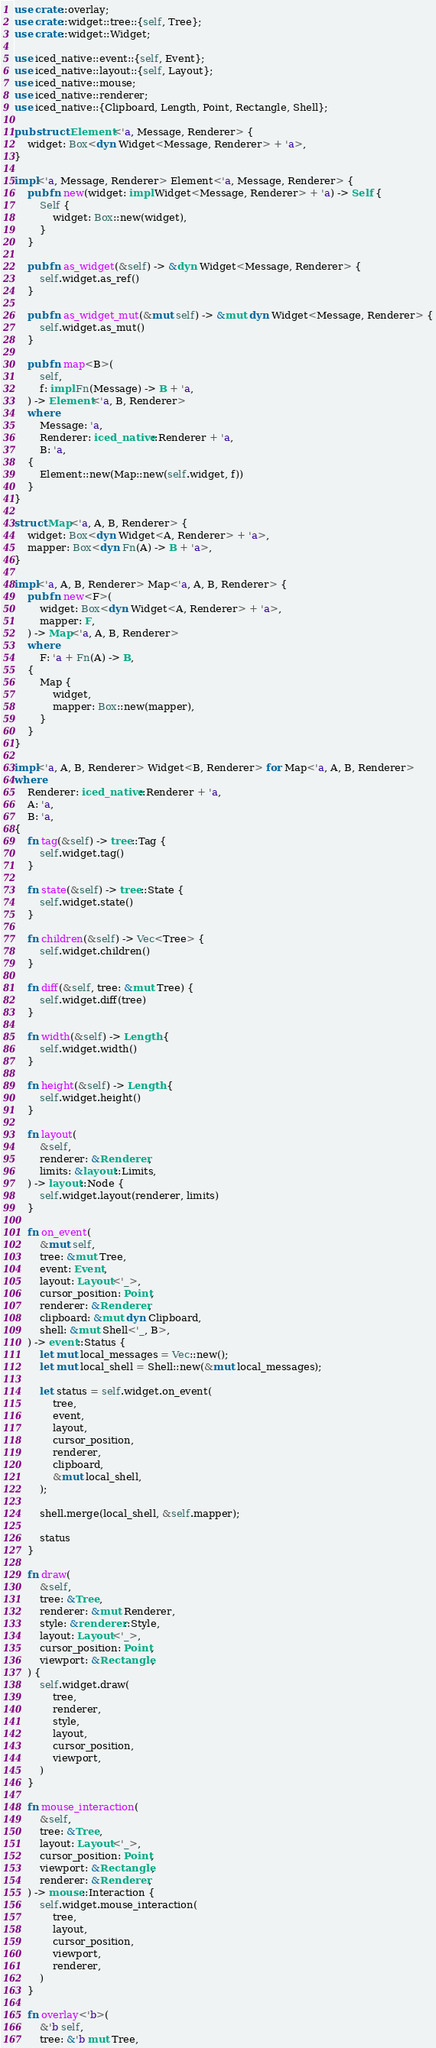Convert code to text. <code><loc_0><loc_0><loc_500><loc_500><_Rust_>use crate::overlay;
use crate::widget::tree::{self, Tree};
use crate::widget::Widget;

use iced_native::event::{self, Event};
use iced_native::layout::{self, Layout};
use iced_native::mouse;
use iced_native::renderer;
use iced_native::{Clipboard, Length, Point, Rectangle, Shell};

pub struct Element<'a, Message, Renderer> {
    widget: Box<dyn Widget<Message, Renderer> + 'a>,
}

impl<'a, Message, Renderer> Element<'a, Message, Renderer> {
    pub fn new(widget: impl Widget<Message, Renderer> + 'a) -> Self {
        Self {
            widget: Box::new(widget),
        }
    }

    pub fn as_widget(&self) -> &dyn Widget<Message, Renderer> {
        self.widget.as_ref()
    }

    pub fn as_widget_mut(&mut self) -> &mut dyn Widget<Message, Renderer> {
        self.widget.as_mut()
    }

    pub fn map<B>(
        self,
        f: impl Fn(Message) -> B + 'a,
    ) -> Element<'a, B, Renderer>
    where
        Message: 'a,
        Renderer: iced_native::Renderer + 'a,
        B: 'a,
    {
        Element::new(Map::new(self.widget, f))
    }
}

struct Map<'a, A, B, Renderer> {
    widget: Box<dyn Widget<A, Renderer> + 'a>,
    mapper: Box<dyn Fn(A) -> B + 'a>,
}

impl<'a, A, B, Renderer> Map<'a, A, B, Renderer> {
    pub fn new<F>(
        widget: Box<dyn Widget<A, Renderer> + 'a>,
        mapper: F,
    ) -> Map<'a, A, B, Renderer>
    where
        F: 'a + Fn(A) -> B,
    {
        Map {
            widget,
            mapper: Box::new(mapper),
        }
    }
}

impl<'a, A, B, Renderer> Widget<B, Renderer> for Map<'a, A, B, Renderer>
where
    Renderer: iced_native::Renderer + 'a,
    A: 'a,
    B: 'a,
{
    fn tag(&self) -> tree::Tag {
        self.widget.tag()
    }

    fn state(&self) -> tree::State {
        self.widget.state()
    }

    fn children(&self) -> Vec<Tree> {
        self.widget.children()
    }

    fn diff(&self, tree: &mut Tree) {
        self.widget.diff(tree)
    }

    fn width(&self) -> Length {
        self.widget.width()
    }

    fn height(&self) -> Length {
        self.widget.height()
    }

    fn layout(
        &self,
        renderer: &Renderer,
        limits: &layout::Limits,
    ) -> layout::Node {
        self.widget.layout(renderer, limits)
    }

    fn on_event(
        &mut self,
        tree: &mut Tree,
        event: Event,
        layout: Layout<'_>,
        cursor_position: Point,
        renderer: &Renderer,
        clipboard: &mut dyn Clipboard,
        shell: &mut Shell<'_, B>,
    ) -> event::Status {
        let mut local_messages = Vec::new();
        let mut local_shell = Shell::new(&mut local_messages);

        let status = self.widget.on_event(
            tree,
            event,
            layout,
            cursor_position,
            renderer,
            clipboard,
            &mut local_shell,
        );

        shell.merge(local_shell, &self.mapper);

        status
    }

    fn draw(
        &self,
        tree: &Tree,
        renderer: &mut Renderer,
        style: &renderer::Style,
        layout: Layout<'_>,
        cursor_position: Point,
        viewport: &Rectangle,
    ) {
        self.widget.draw(
            tree,
            renderer,
            style,
            layout,
            cursor_position,
            viewport,
        )
    }

    fn mouse_interaction(
        &self,
        tree: &Tree,
        layout: Layout<'_>,
        cursor_position: Point,
        viewport: &Rectangle,
        renderer: &Renderer,
    ) -> mouse::Interaction {
        self.widget.mouse_interaction(
            tree,
            layout,
            cursor_position,
            viewport,
            renderer,
        )
    }

    fn overlay<'b>(
        &'b self,
        tree: &'b mut Tree,</code> 